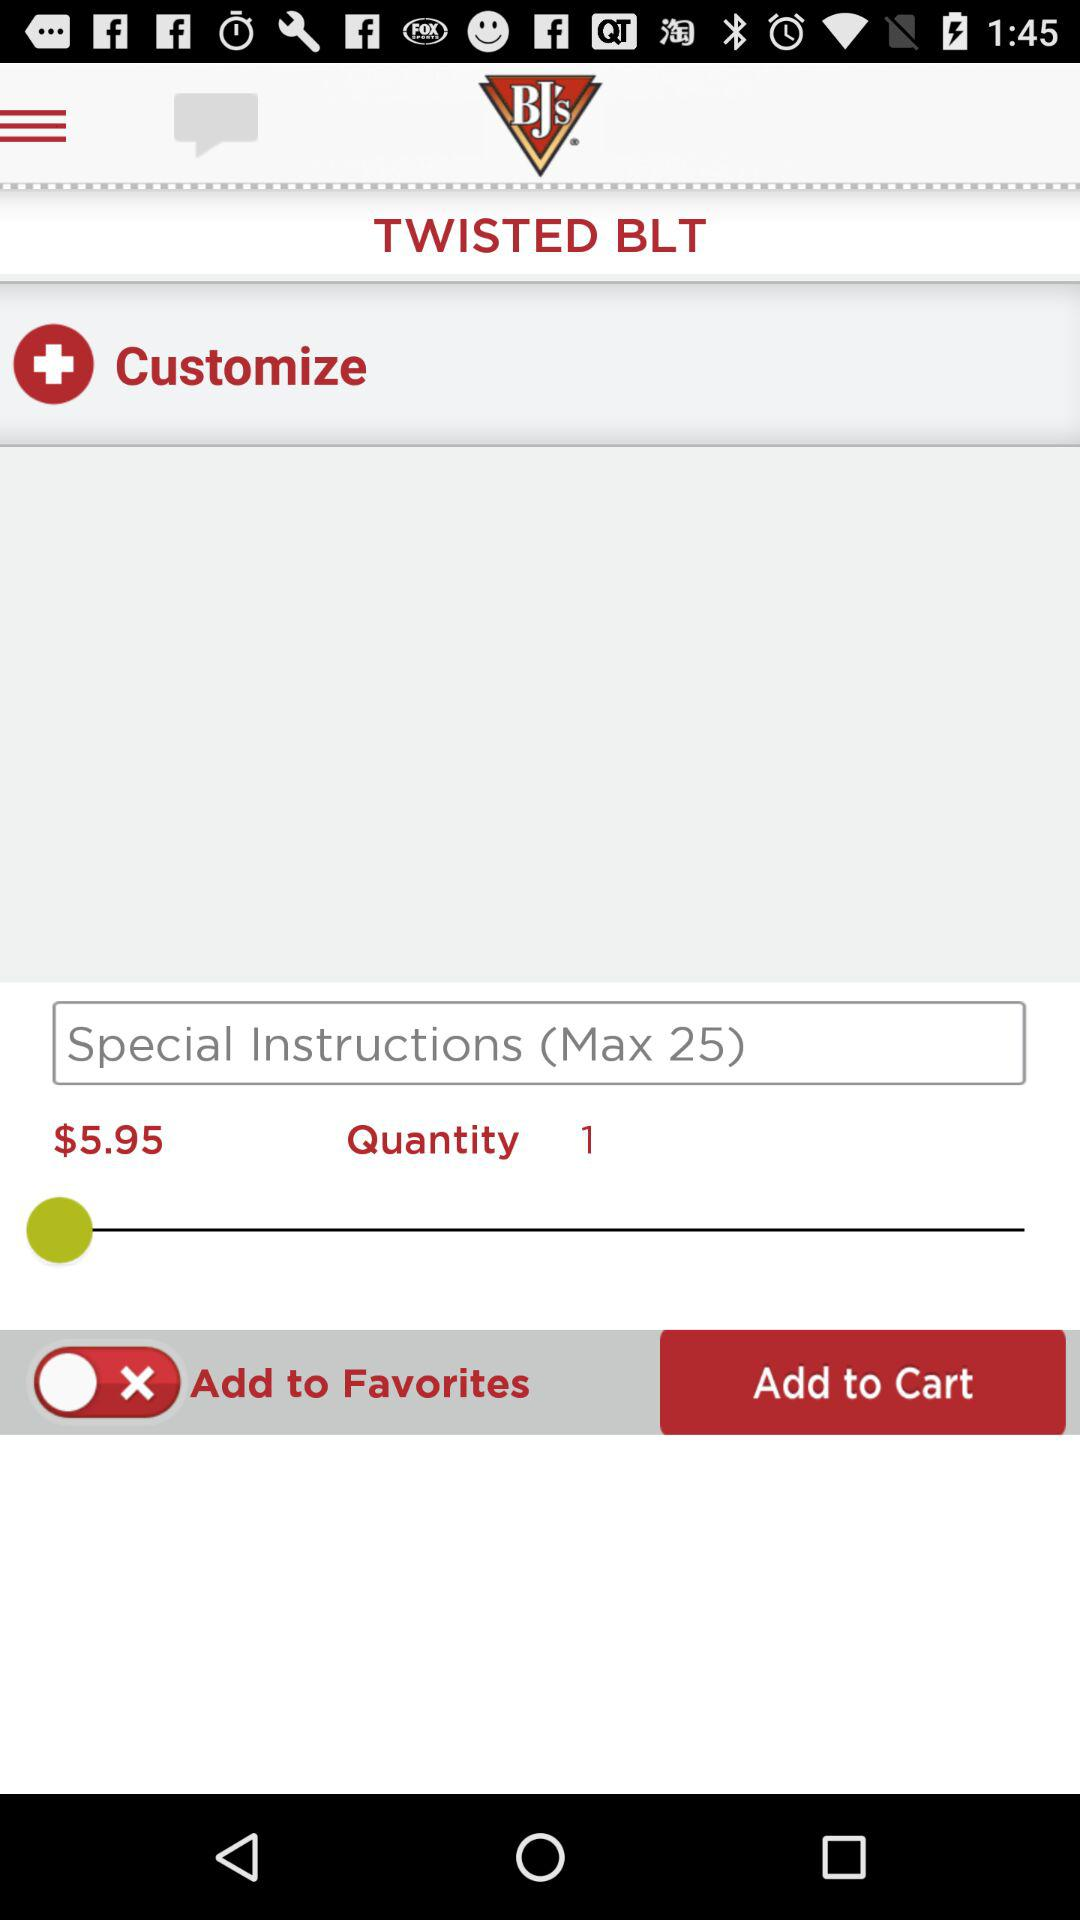What is the price? The price is $5.95. 